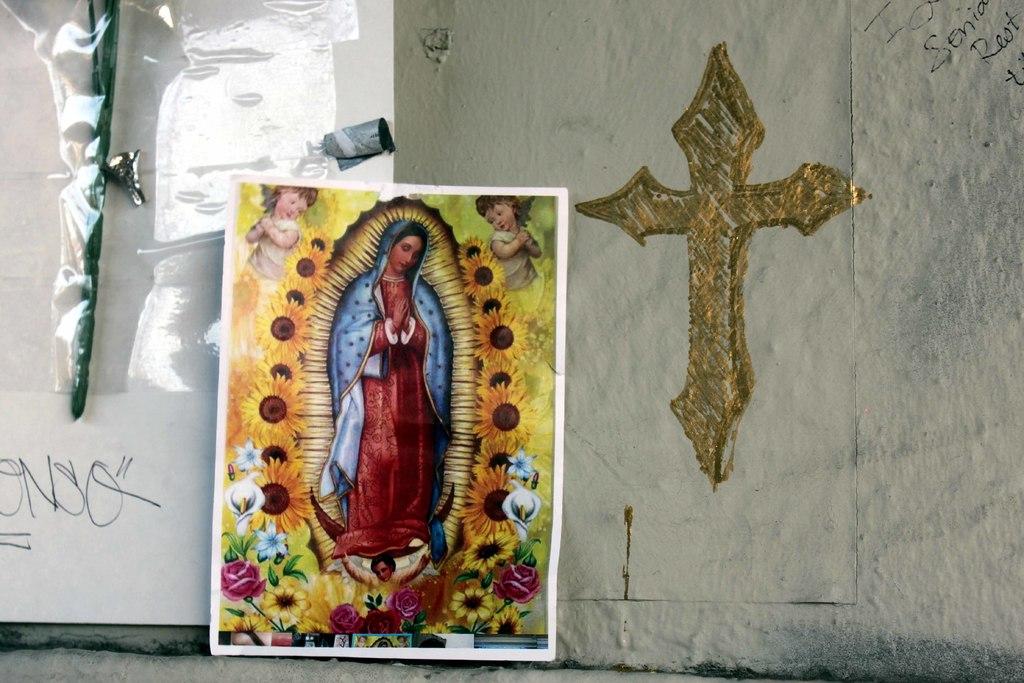What does the text on the left side say?
Your answer should be very brief. Onso. 